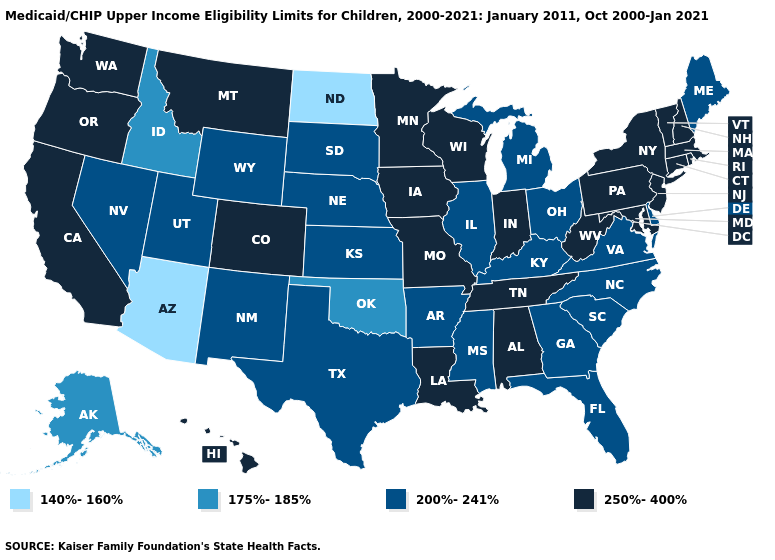Name the states that have a value in the range 140%-160%?
Short answer required. Arizona, North Dakota. What is the lowest value in states that border Montana?
Write a very short answer. 140%-160%. What is the highest value in the West ?
Be succinct. 250%-400%. Name the states that have a value in the range 200%-241%?
Write a very short answer. Arkansas, Delaware, Florida, Georgia, Illinois, Kansas, Kentucky, Maine, Michigan, Mississippi, Nebraska, Nevada, New Mexico, North Carolina, Ohio, South Carolina, South Dakota, Texas, Utah, Virginia, Wyoming. Does Kansas have the same value as Maine?
Short answer required. Yes. What is the value of Idaho?
Quick response, please. 175%-185%. How many symbols are there in the legend?
Answer briefly. 4. What is the value of Oklahoma?
Short answer required. 175%-185%. What is the value of Texas?
Concise answer only. 200%-241%. Does Montana have the highest value in the USA?
Be succinct. Yes. What is the value of North Carolina?
Concise answer only. 200%-241%. Name the states that have a value in the range 250%-400%?
Be succinct. Alabama, California, Colorado, Connecticut, Hawaii, Indiana, Iowa, Louisiana, Maryland, Massachusetts, Minnesota, Missouri, Montana, New Hampshire, New Jersey, New York, Oregon, Pennsylvania, Rhode Island, Tennessee, Vermont, Washington, West Virginia, Wisconsin. What is the value of Washington?
Write a very short answer. 250%-400%. Does Virginia have the same value as Wisconsin?
Short answer required. No. What is the value of New Hampshire?
Write a very short answer. 250%-400%. 